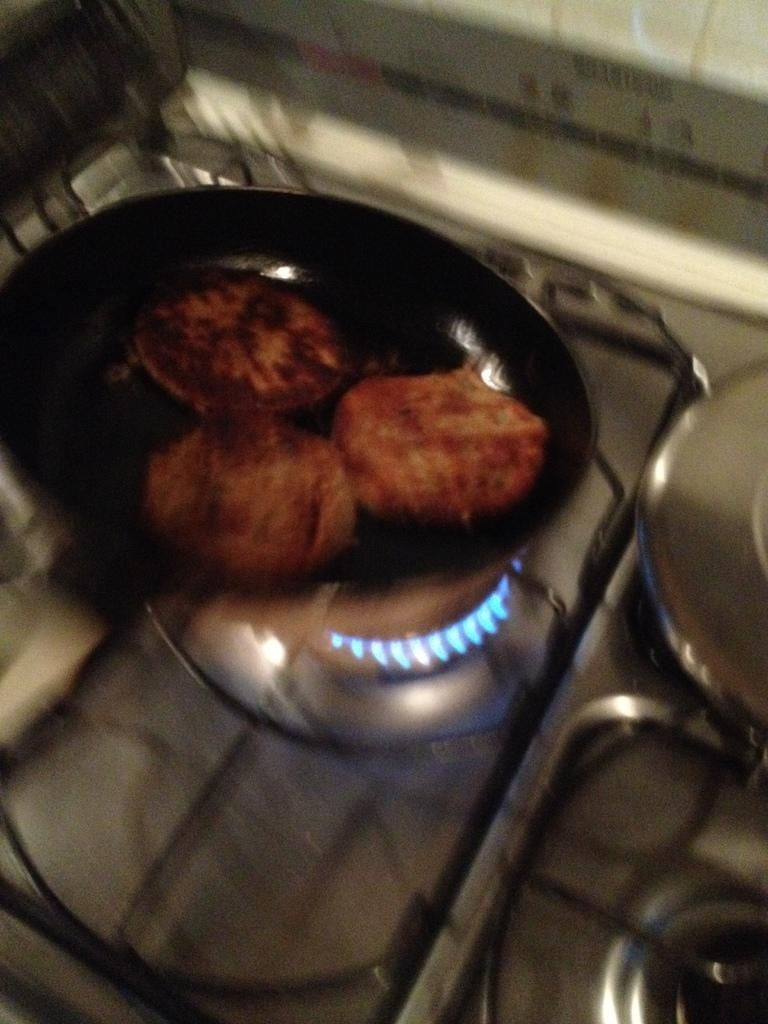What is on the stove in the image? There is a pan on the stove in the image. What is inside the pan on the stove? The pan contains some food. How does the pan sort the food in the image? The pan does not sort the food in the image; it is used for cooking the food. Is there a zipper on the pan in the image? There is no zipper present on the pan in the image. Can you see any icicles hanging from the pan in the image? There are no icicles present in the image, as it features a pan on a stove with food inside. 